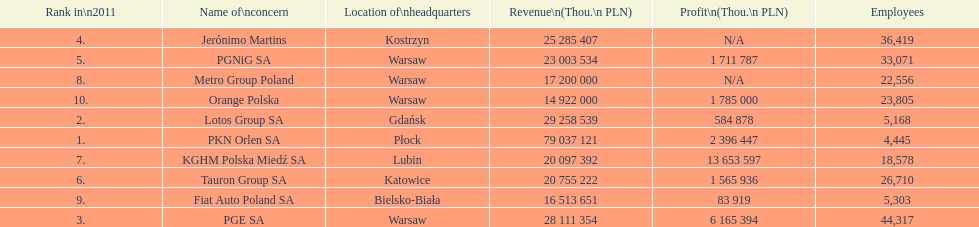What company is the only one with a revenue greater than 75,000,000 thou. pln? PKN Orlen SA. 